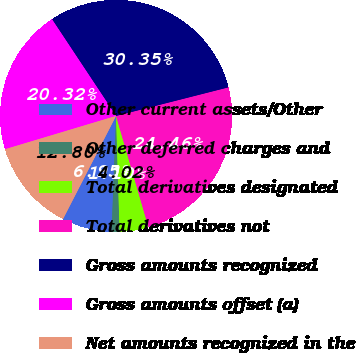Convert chart. <chart><loc_0><loc_0><loc_500><loc_500><pie_chart><fcel>Other current assets/Other<fcel>Other deferred charges and<fcel>Total derivatives designated<fcel>Total derivatives not<fcel>Gross amounts recognized<fcel>Gross amounts offset (a)<fcel>Net amounts recognized in the<nl><fcel>6.95%<fcel>1.1%<fcel>4.02%<fcel>24.46%<fcel>30.35%<fcel>20.32%<fcel>12.8%<nl></chart> 